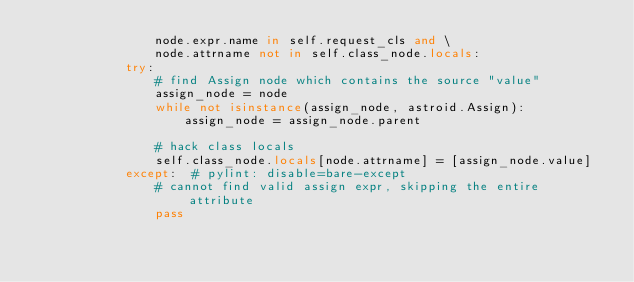Convert code to text. <code><loc_0><loc_0><loc_500><loc_500><_Python_>                node.expr.name in self.request_cls and \
                node.attrname not in self.class_node.locals:
            try:
                # find Assign node which contains the source "value"
                assign_node = node
                while not isinstance(assign_node, astroid.Assign):
                    assign_node = assign_node.parent

                # hack class locals
                self.class_node.locals[node.attrname] = [assign_node.value]
            except:  # pylint: disable=bare-except
                # cannot find valid assign expr, skipping the entire attribute
                pass
</code> 